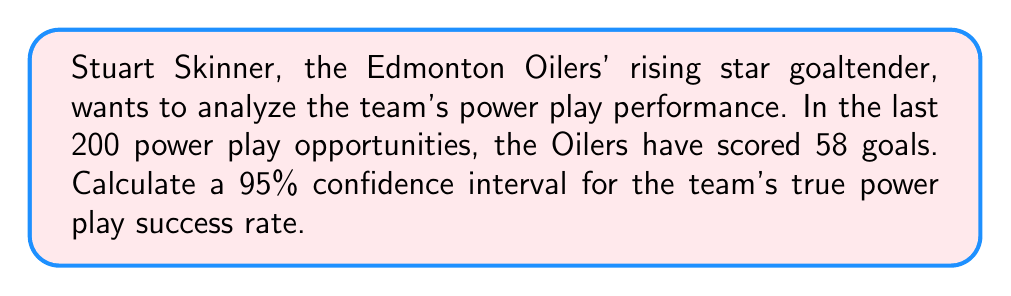Show me your answer to this math problem. Let's approach this step-by-step:

1) First, we need to identify our parameters:
   - Sample size: $n = 200$
   - Number of successes: $X = 58$
   - Confidence level: 95% (so $z_{α/2} = 1.96$)

2) Calculate the sample proportion:
   $\hat{p} = \frac{X}{n} = \frac{58}{200} = 0.29$

3) Calculate the standard error:
   $SE = \sqrt{\frac{\hat{p}(1-\hat{p})}{n}} = \sqrt{\frac{0.29(1-0.29)}{200}} = 0.0321$

4) The formula for the confidence interval is:
   $\hat{p} \pm z_{α/2} \cdot SE$

5) Plugging in our values:
   $0.29 \pm 1.96 \cdot 0.0321$

6) Calculate the margin of error:
   $1.96 \cdot 0.0321 = 0.0629$

7) Therefore, our confidence interval is:
   $0.29 - 0.0629$ to $0.29 + 0.0629$
   $0.2271$ to $0.3529$

8) We can express this as a percentage:
   $22.71\%$ to $35.29\%$
Answer: (22.71%, 35.29%) 